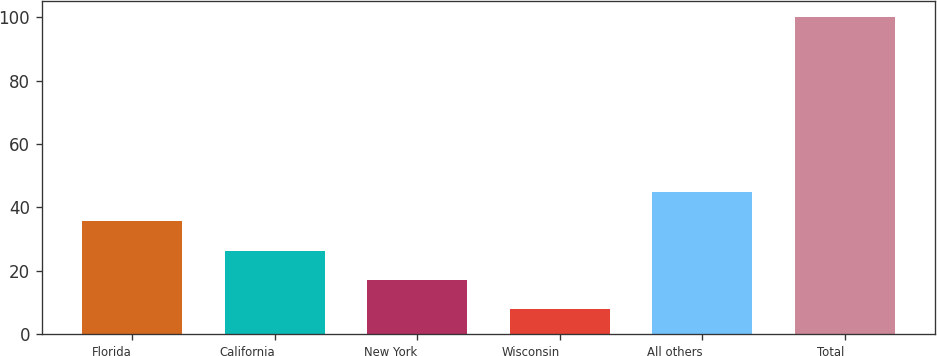Convert chart to OTSL. <chart><loc_0><loc_0><loc_500><loc_500><bar_chart><fcel>Florida<fcel>California<fcel>New York<fcel>Wisconsin<fcel>All others<fcel>Total<nl><fcel>35.6<fcel>26.4<fcel>17.2<fcel>8<fcel>44.8<fcel>100<nl></chart> 